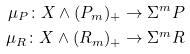Convert formula to latex. <formula><loc_0><loc_0><loc_500><loc_500>\mu _ { P } \colon X \wedge ( P _ { m } ) _ { + } \to \Sigma ^ { m } P \\ \mu _ { R } \colon X \wedge ( R _ { m } ) _ { + } \to \Sigma ^ { m } R</formula> 